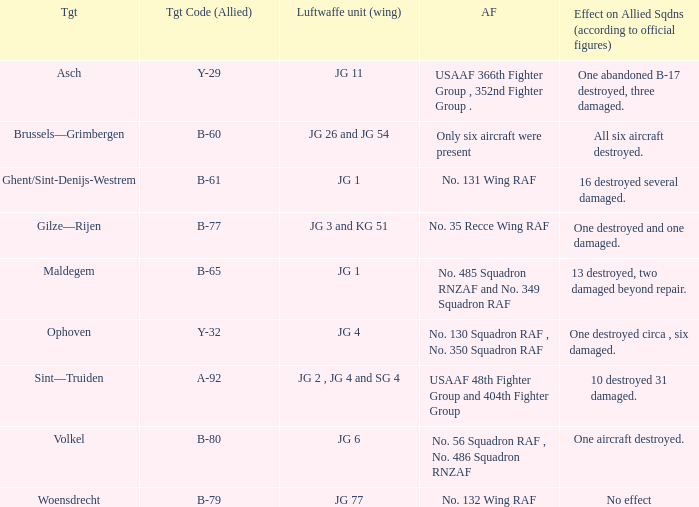Which Allied Force targetted Woensdrecht? No. 132 Wing RAF. 